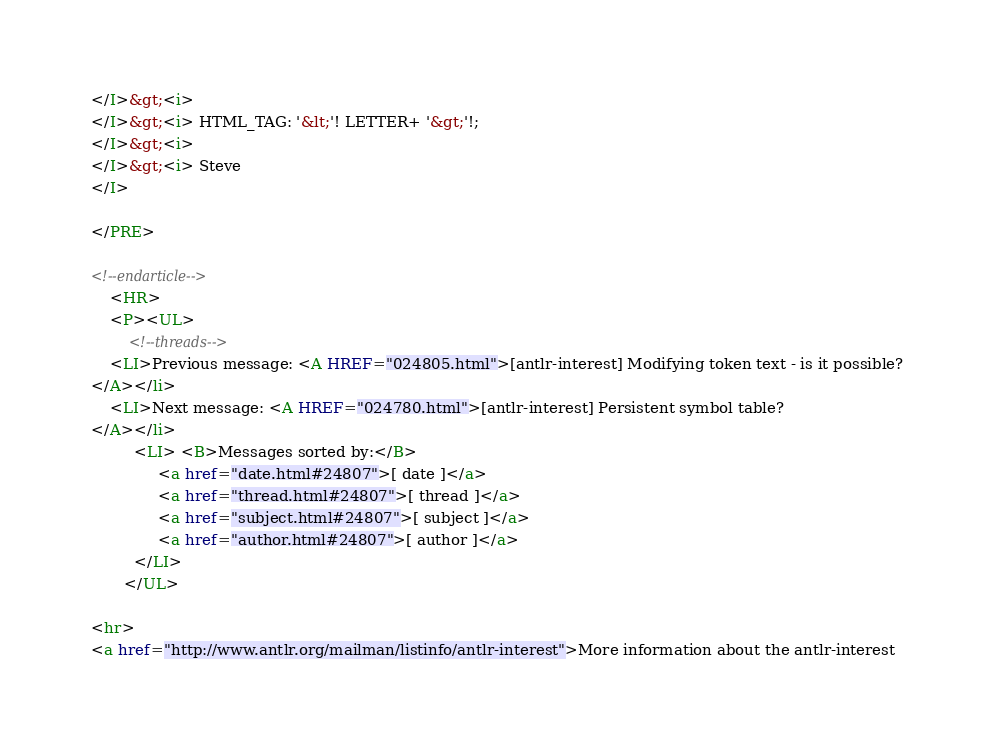Convert code to text. <code><loc_0><loc_0><loc_500><loc_500><_HTML_></I>&gt;<i> 
</I>&gt;<i> HTML_TAG: '&lt;'! LETTER+ '&gt;'!;
</I>&gt;<i> 
</I>&gt;<i> Steve
</I>

</PRE>

<!--endarticle-->
    <HR>
    <P><UL>
        <!--threads-->
	<LI>Previous message: <A HREF="024805.html">[antlr-interest] Modifying token text - is it possible?
</A></li>
	<LI>Next message: <A HREF="024780.html">[antlr-interest] Persistent symbol table?
</A></li>
         <LI> <B>Messages sorted by:</B> 
              <a href="date.html#24807">[ date ]</a>
              <a href="thread.html#24807">[ thread ]</a>
              <a href="subject.html#24807">[ subject ]</a>
              <a href="author.html#24807">[ author ]</a>
         </LI>
       </UL>

<hr>
<a href="http://www.antlr.org/mailman/listinfo/antlr-interest">More information about the antlr-interest</code> 